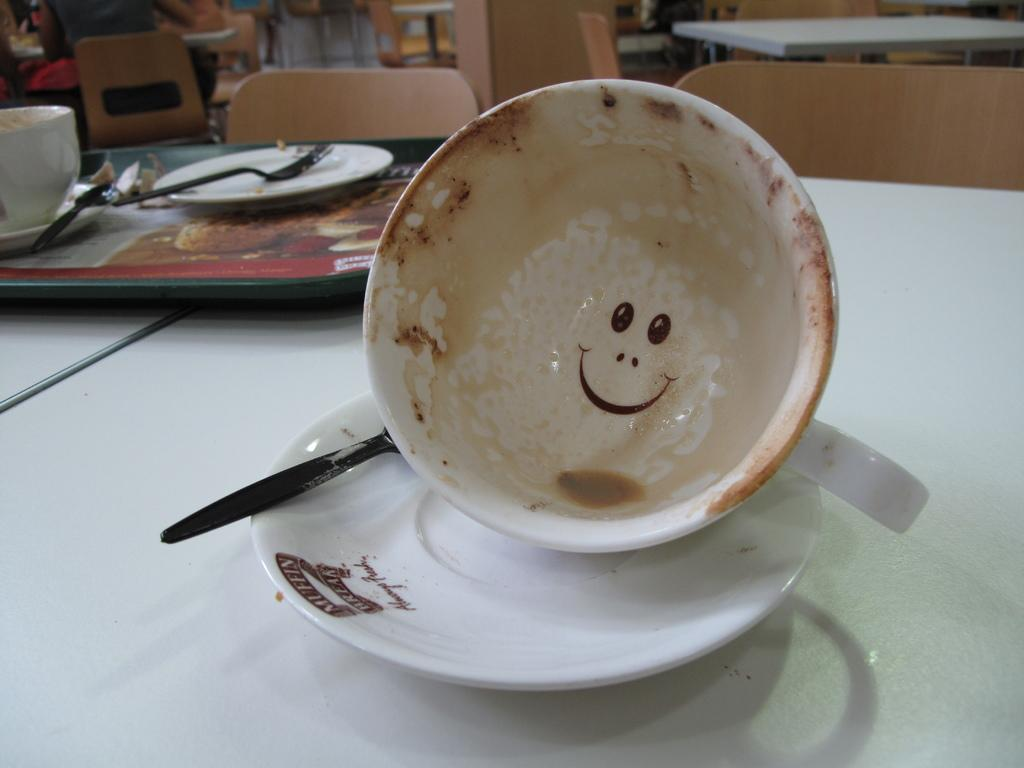What objects are on the table in the image? There are cups, saucers, and spoons on a table in the image. What type of furniture can be seen in the background? There are chairs and tables in the background. Are there any people present in the image? Yes, there are people in the background. What type of hen is sitting on the table in the image? There is no hen present on the table or in the image. 